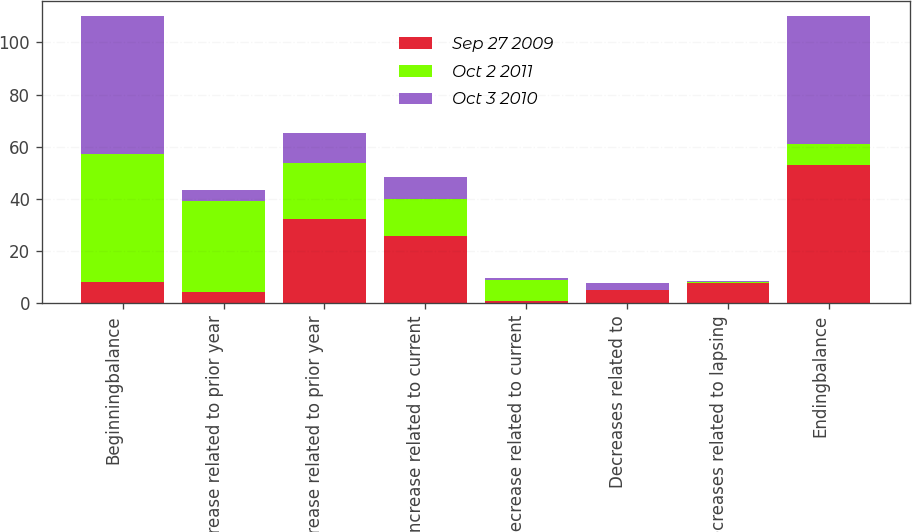Convert chart to OTSL. <chart><loc_0><loc_0><loc_500><loc_500><stacked_bar_chart><ecel><fcel>Beginningbalance<fcel>Increase related to prior year<fcel>Decrease related to prior year<fcel>Increase related to current<fcel>Decrease related to current<fcel>Decreases related to<fcel>Decreases related to lapsing<fcel>Endingbalance<nl><fcel>Sep 27 2009<fcel>8.25<fcel>4.4<fcel>32.3<fcel>26<fcel>0.8<fcel>5<fcel>7.8<fcel>52.9<nl><fcel>Oct 2 2011<fcel>49.1<fcel>35<fcel>21.4<fcel>14.1<fcel>8.1<fcel>0<fcel>0.3<fcel>8.25<nl><fcel>Oct 3 2010<fcel>52.6<fcel>4.2<fcel>11.6<fcel>8.4<fcel>0.9<fcel>3<fcel>0.6<fcel>49.1<nl></chart> 